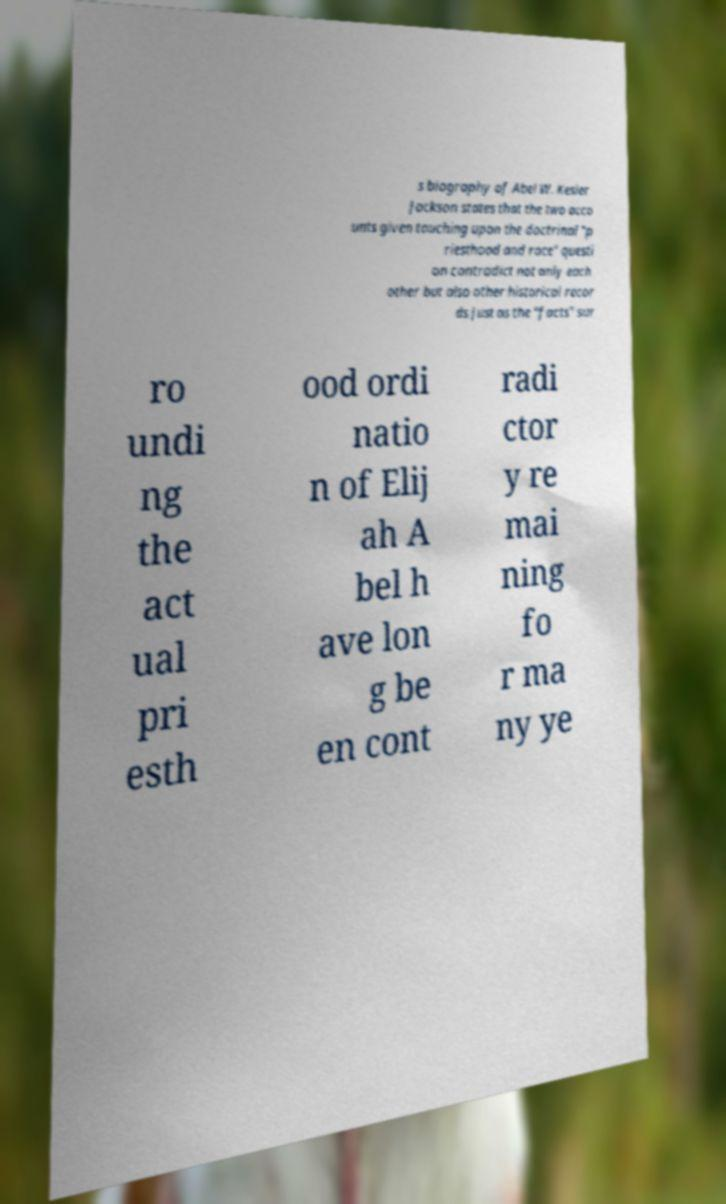I need the written content from this picture converted into text. Can you do that? s biography of Abel W. Kesler Jackson states that the two acco unts given touching upon the doctrinal "p riesthood and race" questi on contradict not only each other but also other historical recor ds just as the "facts" sur ro undi ng the act ual pri esth ood ordi natio n of Elij ah A bel h ave lon g be en cont radi ctor y re mai ning fo r ma ny ye 